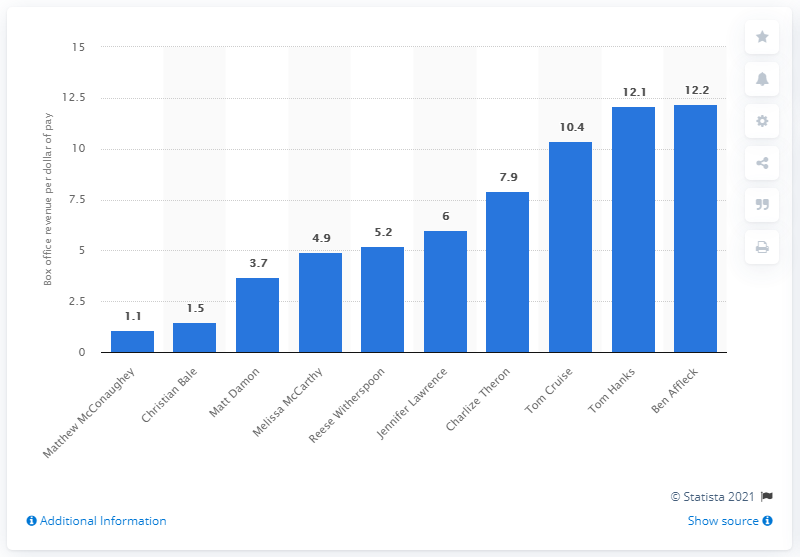Who has the lowest return on this list and why might that be? Matthew McConaughey has the lowest return on the list at $1.1 per dollar paid. This could be due to a variety of factors, such as starring in movies with lower box office revenue or higher production budgets not matched by corresponding ticket sales. 